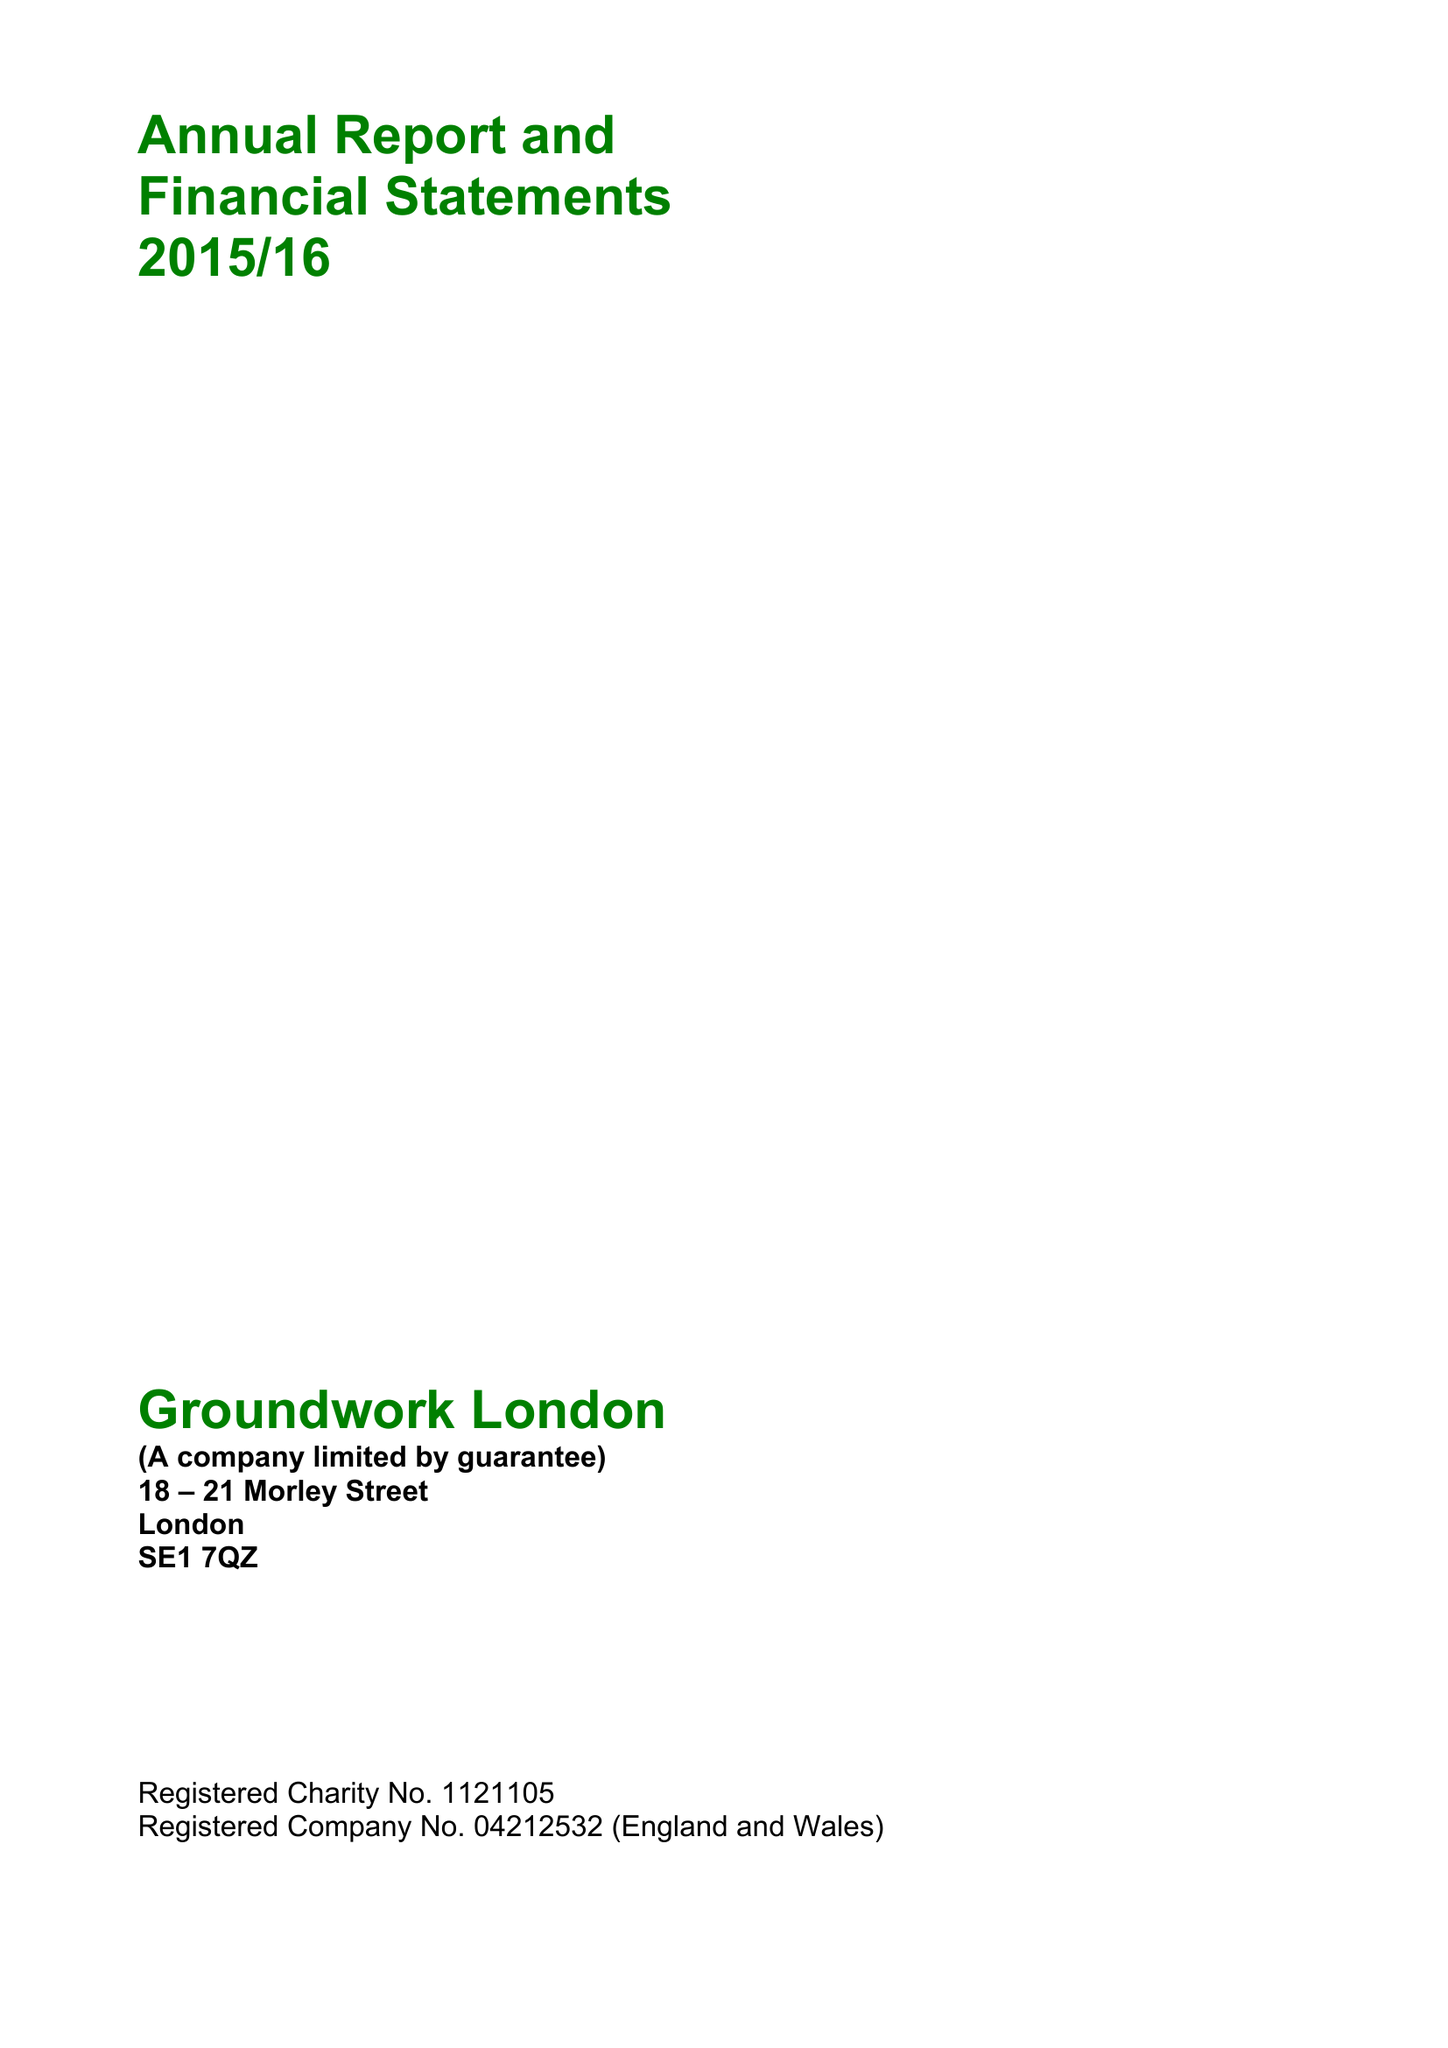What is the value for the charity_number?
Answer the question using a single word or phrase. 1121105 